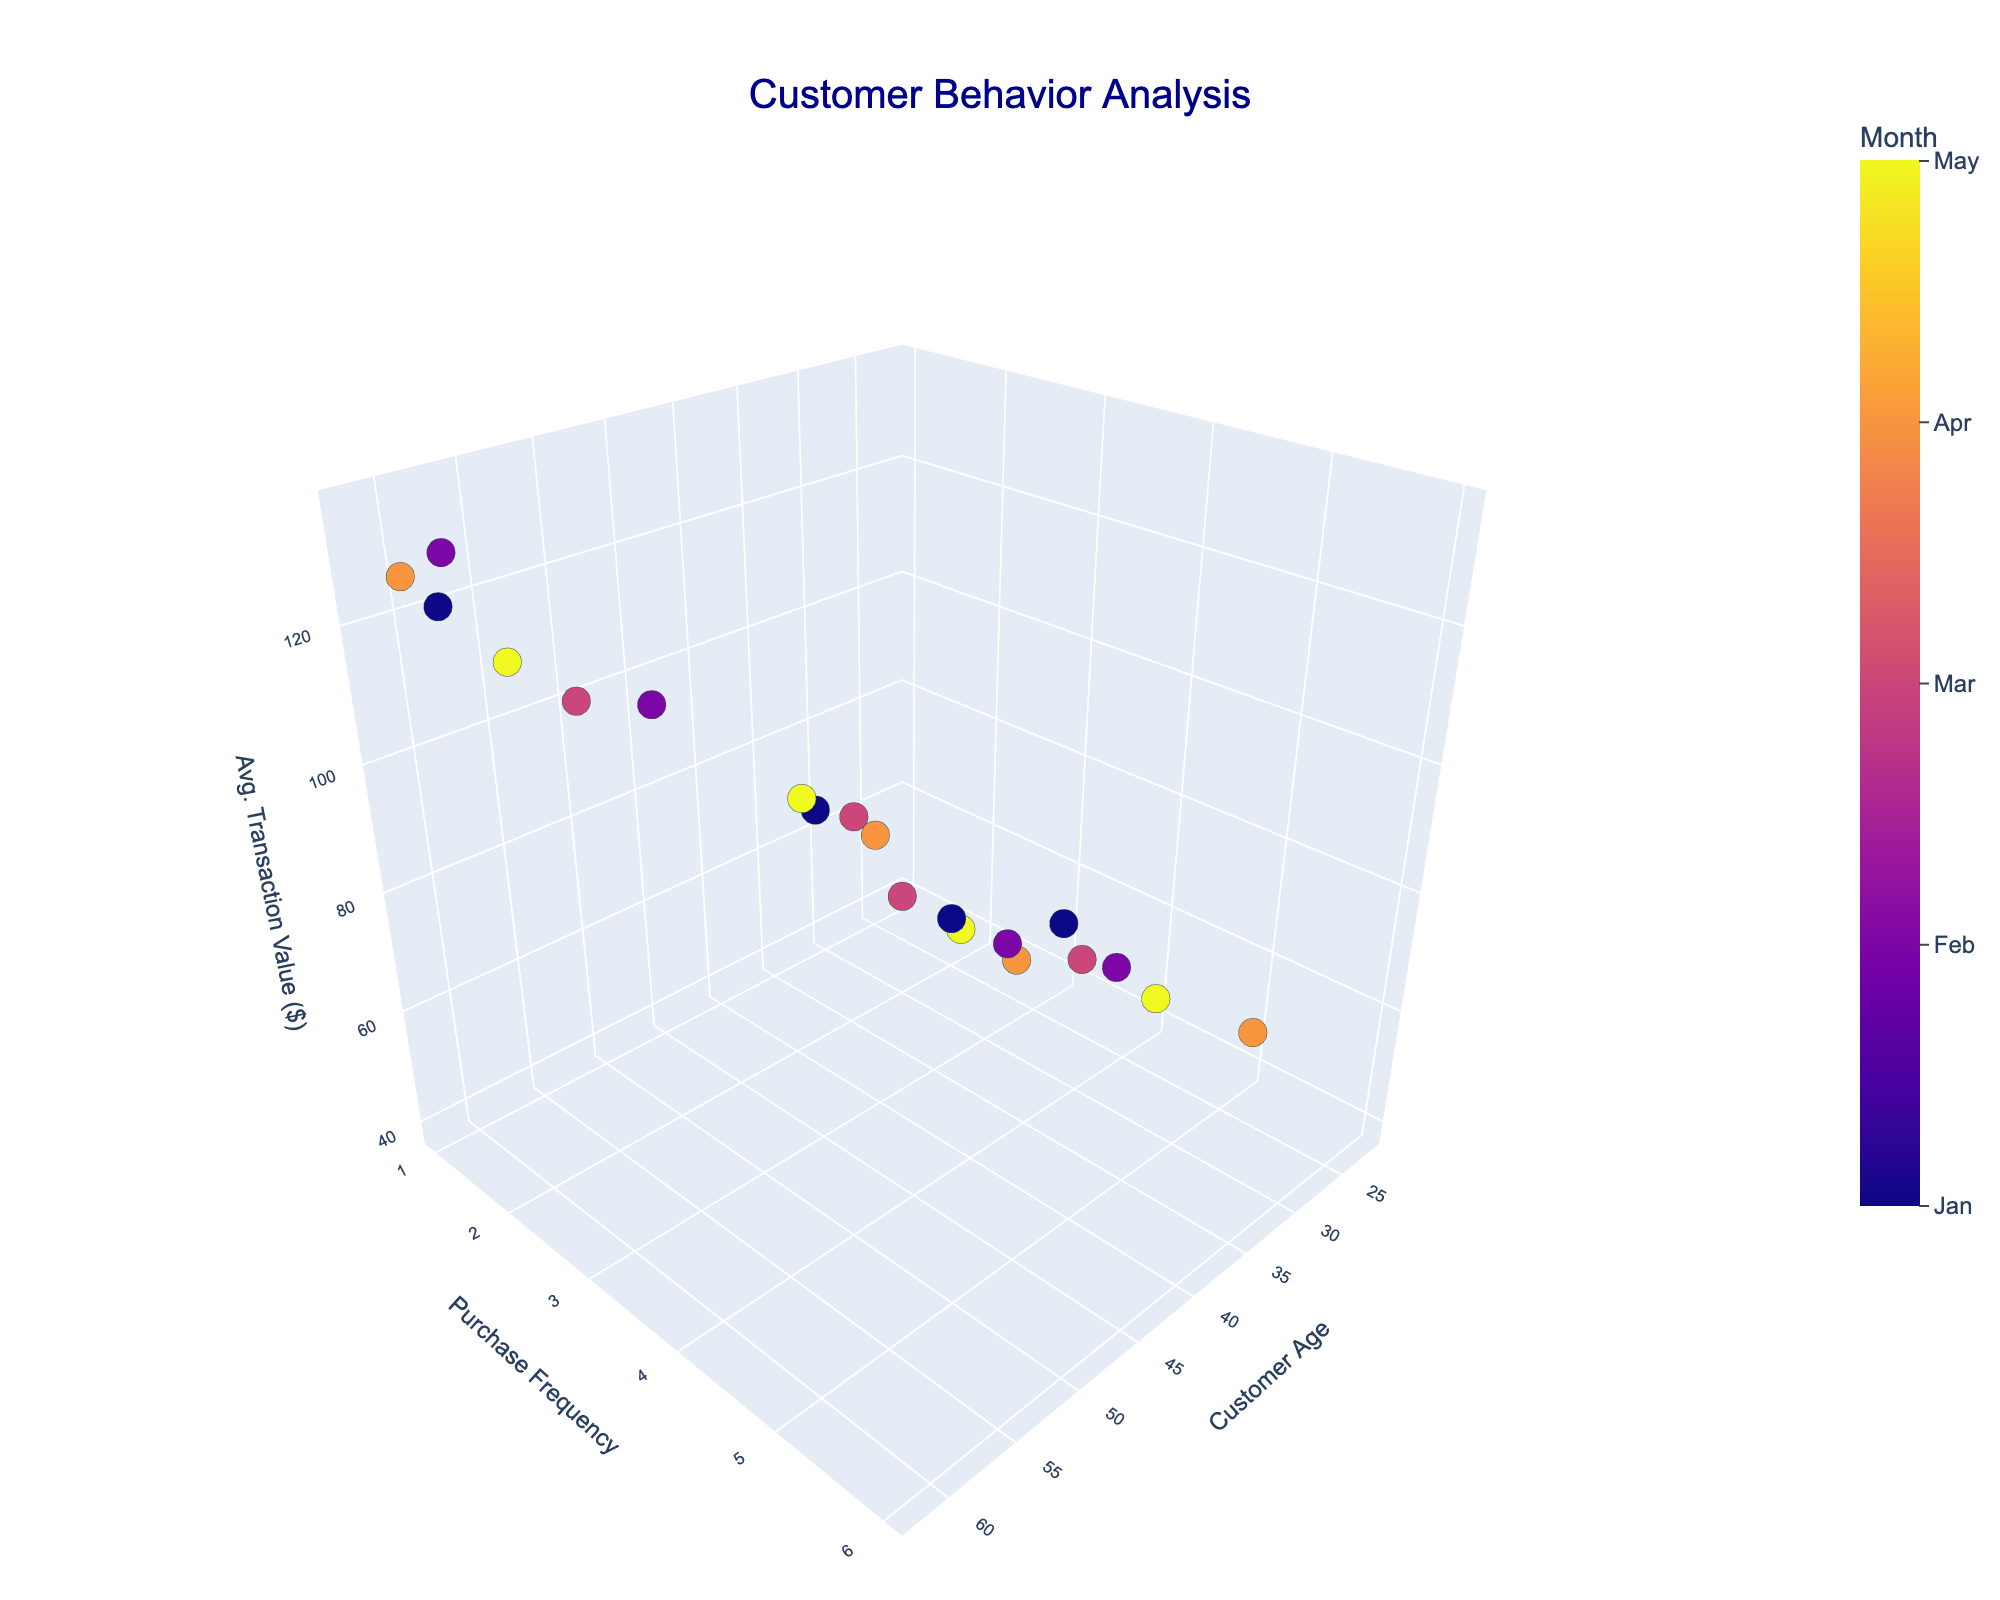What is the title of the figure? The title is usually located at the top of the figure. It reads "Customer Behavior Analysis."
Answer: Customer Behavior Analysis What age group had the highest purchase frequency in April? Look for the data points labeled with "Apr" and check the y-axis (Purchase Frequency). The highest value is for the age group 35.
Answer: 35 How does the average transaction value change for customers aged 45 across different months? Identify the data points for age 45 and check the z-axis (Average Transaction Value) for each month. In January, it is 92.30; in May, it is 95.00.
Answer: Increases from January to May Which month has the highest average transaction value and what is that value? Compare the z-axis (Average Transaction Value) of data points marked with each month's color. April has the highest value, particularly for age 60, which is 125.50.
Answer: April, 125.50 What is the purchase frequency of customers aged 22 in March? Find the data point for age 22 labeled with "Mar" and check the y-axis for Purchase Frequency.
Answer: 1 Compare the purchase frequency of customers aged 50 and 59 in May. Which is higher? Locate the data points for ages 50 and 59 labeled with "May" and compare their y-axis values. Age 50 has a value of 2, while age 59 also has a value of 2.
Answer: Equal What is the trend in purchase frequency for customers aged 28 and 33 across different months? Look at the data points for ages 28 and 33 and observe their y-axis values over time. Age 28 starts with a purchase frequency of 3 in February, while age 33 starts with 5 in May. Age 33 has a steady purchase frequency of 5.
Answer: Purchase frequency for 28 is 3, for 33 remains steady at 5 How does the average transaction value of customers aged 30 compare to those aged 42 in March? Locate the data points for ages 30 and 42 in March and compare their z-axis values. Age 30 has 60.25, and age 42 has 88.50.
Answer: Age 42 has a higher value What is the highest average transaction value recorded and which age group does it belong to? Check the z-axis for the highest value across all data points. The maximum value is 135.00, belonging to age 62 in February.
Answer: 135.00, age 62 in February 